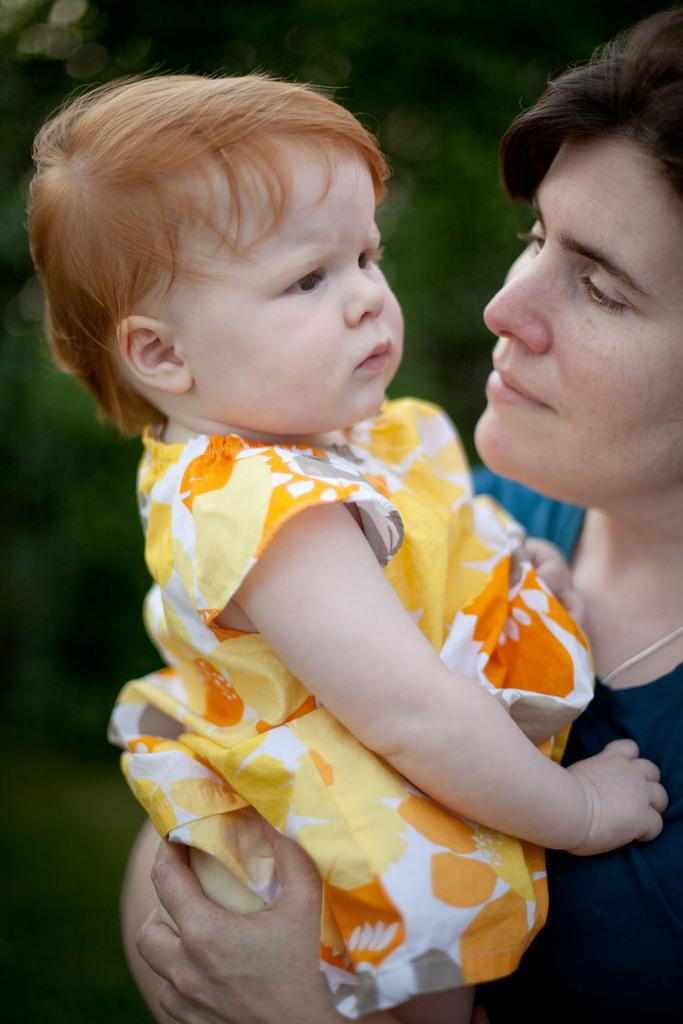Who is the main subject in the image? There is a lady in the image. What is the lady doing in the image? The lady is carrying a baby. What type of quilt is being used to cover the ice in the image? There is no quilt or ice present in the image; it features a lady carrying a baby. Who is the representative of the baby in the image? The baby does not have a representative in the image; the lady is carrying the baby directly. 